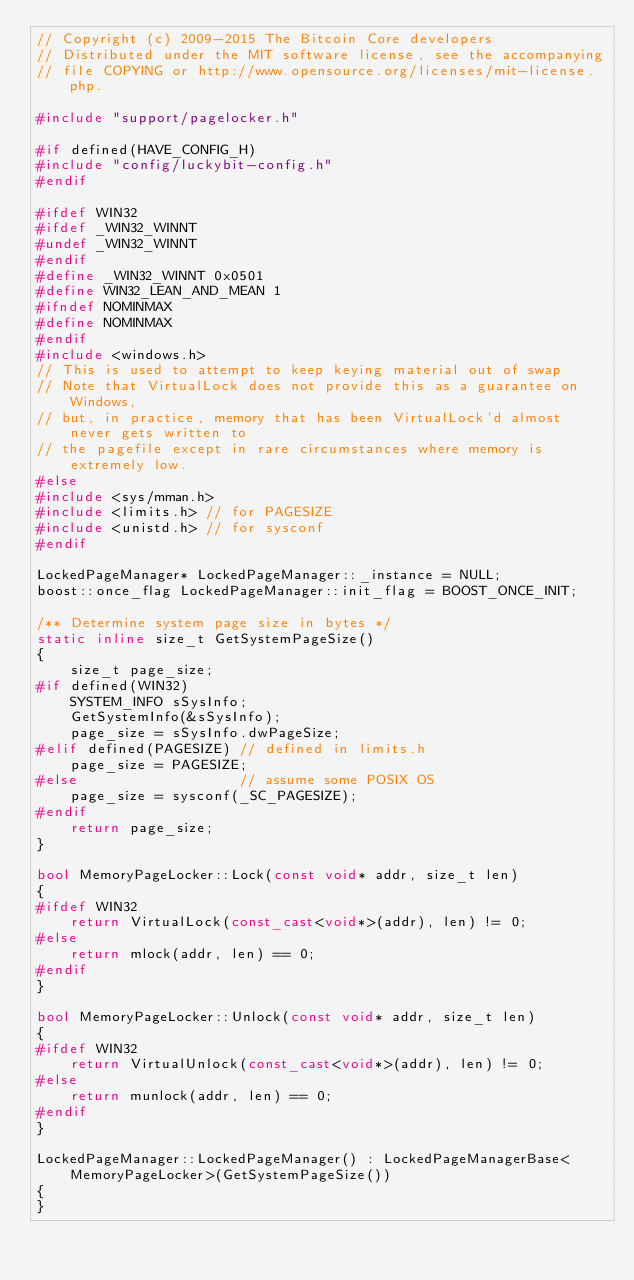Convert code to text. <code><loc_0><loc_0><loc_500><loc_500><_C++_>// Copyright (c) 2009-2015 The Bitcoin Core developers
// Distributed under the MIT software license, see the accompanying
// file COPYING or http://www.opensource.org/licenses/mit-license.php.

#include "support/pagelocker.h"

#if defined(HAVE_CONFIG_H)
#include "config/luckybit-config.h"
#endif

#ifdef WIN32
#ifdef _WIN32_WINNT
#undef _WIN32_WINNT
#endif
#define _WIN32_WINNT 0x0501
#define WIN32_LEAN_AND_MEAN 1
#ifndef NOMINMAX
#define NOMINMAX
#endif
#include <windows.h>
// This is used to attempt to keep keying material out of swap
// Note that VirtualLock does not provide this as a guarantee on Windows,
// but, in practice, memory that has been VirtualLock'd almost never gets written to
// the pagefile except in rare circumstances where memory is extremely low.
#else
#include <sys/mman.h>
#include <limits.h> // for PAGESIZE
#include <unistd.h> // for sysconf
#endif

LockedPageManager* LockedPageManager::_instance = NULL;
boost::once_flag LockedPageManager::init_flag = BOOST_ONCE_INIT;

/** Determine system page size in bytes */
static inline size_t GetSystemPageSize()
{
    size_t page_size;
#if defined(WIN32)
    SYSTEM_INFO sSysInfo;
    GetSystemInfo(&sSysInfo);
    page_size = sSysInfo.dwPageSize;
#elif defined(PAGESIZE) // defined in limits.h
    page_size = PAGESIZE;
#else                   // assume some POSIX OS
    page_size = sysconf(_SC_PAGESIZE);
#endif
    return page_size;
}

bool MemoryPageLocker::Lock(const void* addr, size_t len)
{
#ifdef WIN32
    return VirtualLock(const_cast<void*>(addr), len) != 0;
#else
    return mlock(addr, len) == 0;
#endif
}

bool MemoryPageLocker::Unlock(const void* addr, size_t len)
{
#ifdef WIN32
    return VirtualUnlock(const_cast<void*>(addr), len) != 0;
#else
    return munlock(addr, len) == 0;
#endif
}

LockedPageManager::LockedPageManager() : LockedPageManagerBase<MemoryPageLocker>(GetSystemPageSize())
{
}
</code> 